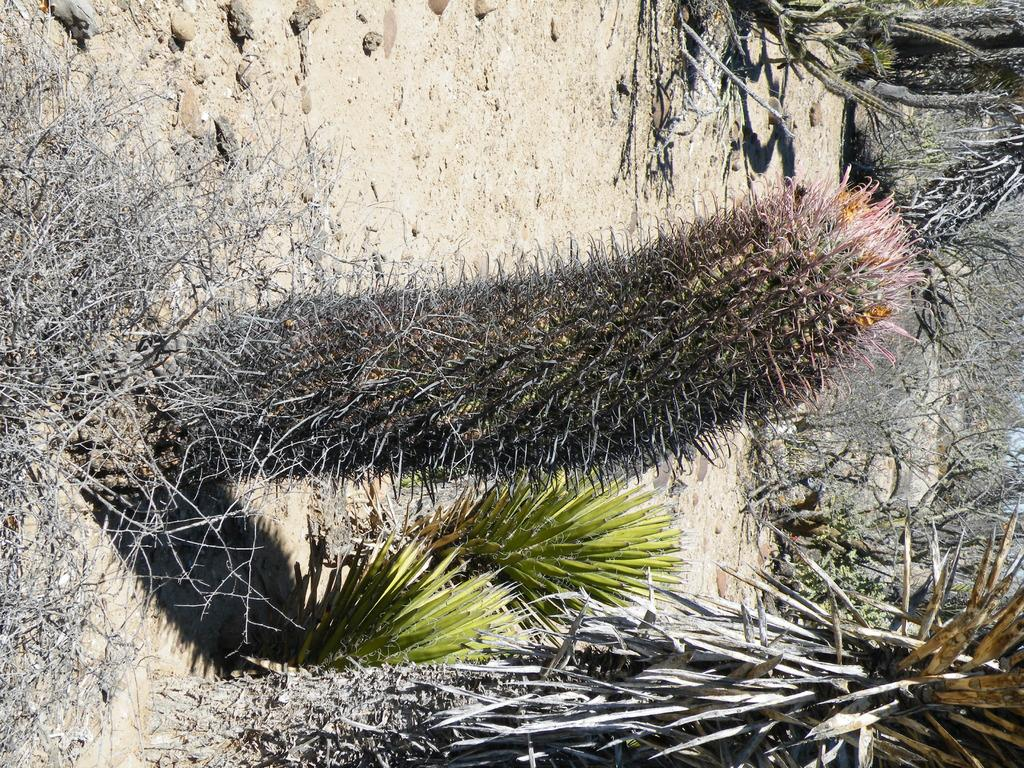What type of plants can be seen in the image? There are cactus plants with thorns in the image. What is located on the right side of the image? There are trees on the right side of the image. What type of ground cover can be seen in the image? Small rocks are lying on the ground in the image. What type of picture is hanging on the wall in the image? There is no mention of a picture or a wall in the provided facts, so we cannot answer this question. 